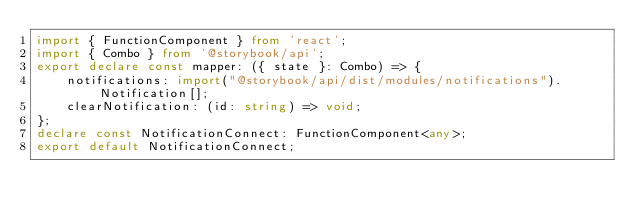Convert code to text. <code><loc_0><loc_0><loc_500><loc_500><_TypeScript_>import { FunctionComponent } from 'react';
import { Combo } from '@storybook/api';
export declare const mapper: ({ state }: Combo) => {
    notifications: import("@storybook/api/dist/modules/notifications").Notification[];
    clearNotification: (id: string) => void;
};
declare const NotificationConnect: FunctionComponent<any>;
export default NotificationConnect;
</code> 